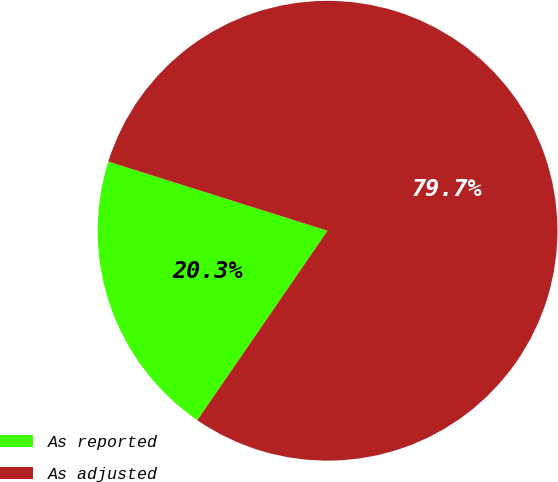<chart> <loc_0><loc_0><loc_500><loc_500><pie_chart><fcel>As reported<fcel>As adjusted<nl><fcel>20.28%<fcel>79.72%<nl></chart> 